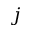<formula> <loc_0><loc_0><loc_500><loc_500>j</formula> 